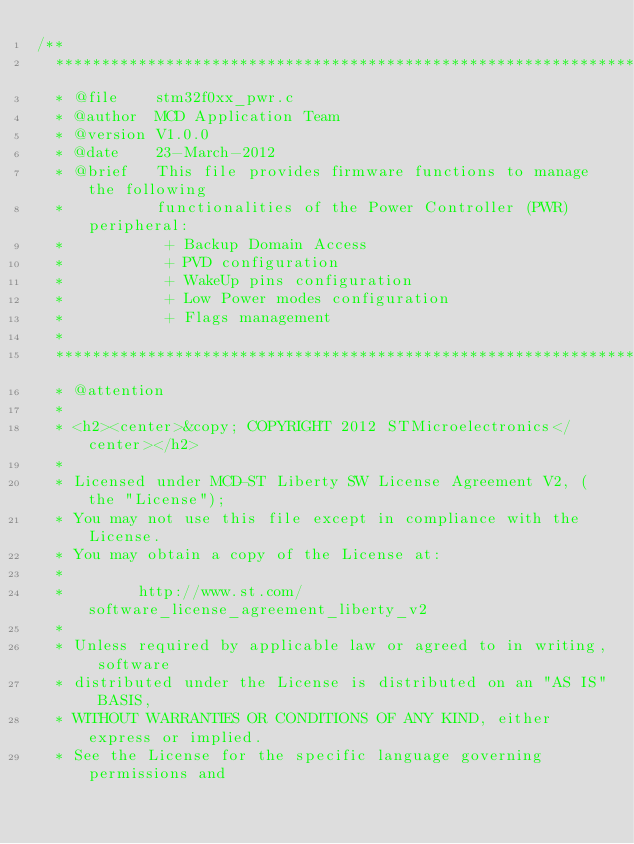Convert code to text. <code><loc_0><loc_0><loc_500><loc_500><_C_>/**
  ******************************************************************************
  * @file    stm32f0xx_pwr.c
  * @author  MCD Application Team
  * @version V1.0.0
  * @date    23-March-2012
  * @brief   This file provides firmware functions to manage the following 
  *          functionalities of the Power Controller (PWR) peripheral:
  *           + Backup Domain Access
  *           + PVD configuration
  *           + WakeUp pins configuration
  *           + Low Power modes configuration
  *           + Flags management
  *
  ******************************************************************************
  * @attention
  *
  * <h2><center>&copy; COPYRIGHT 2012 STMicroelectronics</center></h2>
  *
  * Licensed under MCD-ST Liberty SW License Agreement V2, (the "License");
  * You may not use this file except in compliance with the License.
  * You may obtain a copy of the License at:
  *
  *        http://www.st.com/software_license_agreement_liberty_v2
  *
  * Unless required by applicable law or agreed to in writing, software 
  * distributed under the License is distributed on an "AS IS" BASIS, 
  * WITHOUT WARRANTIES OR CONDITIONS OF ANY KIND, either express or implied.
  * See the License for the specific language governing permissions and</code> 